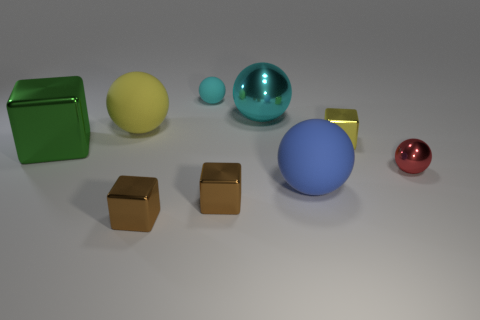Subtract all big metal balls. How many balls are left? 4 Subtract all blue spheres. How many spheres are left? 4 Subtract all brown balls. Subtract all gray cubes. How many balls are left? 5 Add 1 yellow metal cubes. How many objects exist? 10 Subtract all balls. How many objects are left? 4 Subtract all large cyan metallic objects. Subtract all green metal cubes. How many objects are left? 7 Add 7 metal balls. How many metal balls are left? 9 Add 3 tiny red metal balls. How many tiny red metal balls exist? 4 Subtract 0 brown spheres. How many objects are left? 9 